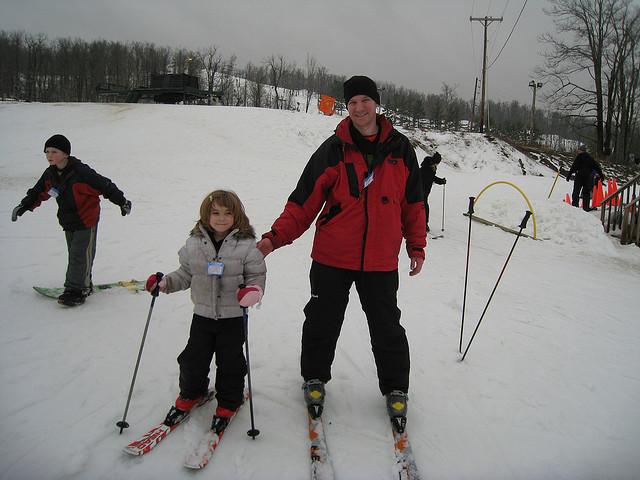How many people are in the picture?
Write a very short answer. 4. What are the three people wearing on their faces?
Keep it brief. Smiles. Is there snow?
Write a very short answer. Yes. How many ski poles is the man physically holding in the picture?
Concise answer only. 0. Is the man teaching the kids how to ski?
Keep it brief. Yes. Is the man wearing glasses?
Quick response, please. No. Is the man helping his daughter ski?
Concise answer only. Yes. 